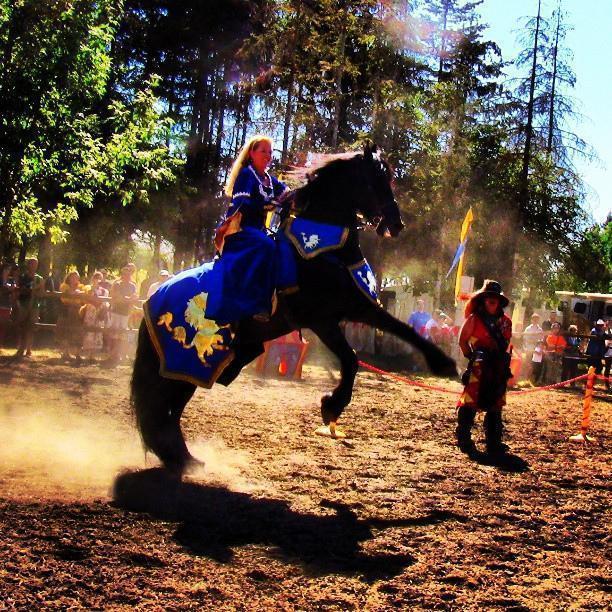What attire is the person standing behind the horse in front of the red rope wearing?
Select the accurate answer and provide explanation: 'Answer: answer
Rationale: rationale.'
Options: Australian ranger, police officer, native american, latin american. Answer: native american.
Rationale: The person is wearing leather and traditional clothing. 